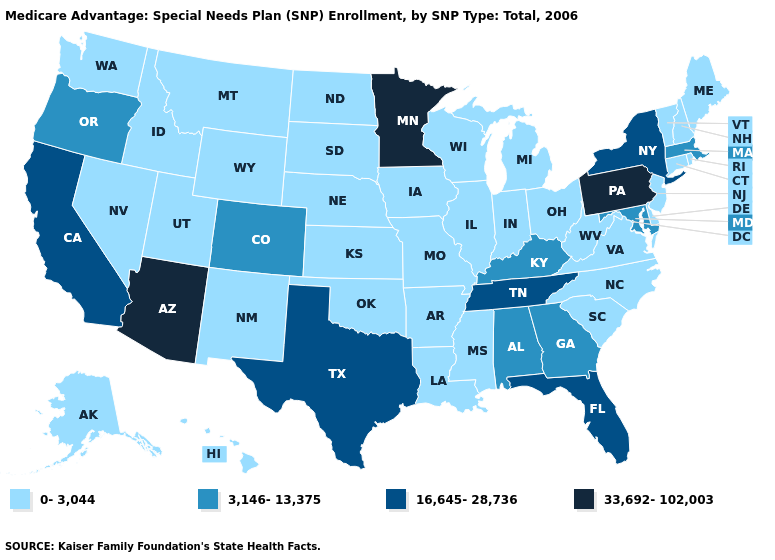What is the value of Indiana?
Keep it brief. 0-3,044. What is the value of Pennsylvania?
Keep it brief. 33,692-102,003. Does Iowa have the lowest value in the USA?
Quick response, please. Yes. Which states hav the highest value in the West?
Short answer required. Arizona. What is the highest value in the MidWest ?
Answer briefly. 33,692-102,003. Name the states that have a value in the range 3,146-13,375?
Quick response, please. Alabama, Colorado, Georgia, Kentucky, Massachusetts, Maryland, Oregon. Which states hav the highest value in the South?
Answer briefly. Florida, Tennessee, Texas. What is the value of Wisconsin?
Concise answer only. 0-3,044. Does Minnesota have the highest value in the USA?
Keep it brief. Yes. What is the value of Florida?
Write a very short answer. 16,645-28,736. Name the states that have a value in the range 3,146-13,375?
Answer briefly. Alabama, Colorado, Georgia, Kentucky, Massachusetts, Maryland, Oregon. What is the value of Ohio?
Write a very short answer. 0-3,044. What is the lowest value in the USA?
Be succinct. 0-3,044. Name the states that have a value in the range 33,692-102,003?
Quick response, please. Arizona, Minnesota, Pennsylvania. What is the value of New Hampshire?
Concise answer only. 0-3,044. 